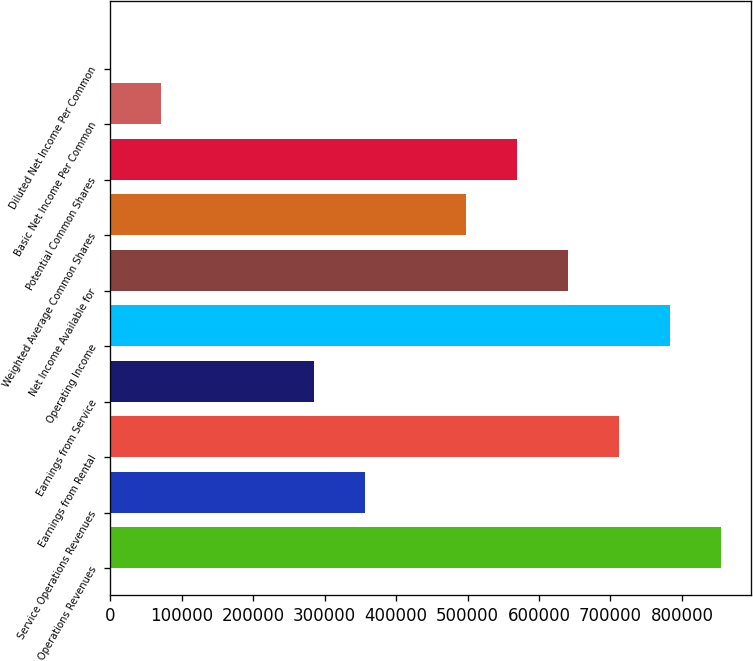Convert chart to OTSL. <chart><loc_0><loc_0><loc_500><loc_500><bar_chart><fcel>Rental Operations Revenues<fcel>Service Operations Revenues<fcel>Earnings from Rental<fcel>Earnings from Service<fcel>Operating Income<fcel>Net Income Available for<fcel>Weighted Average Common Shares<fcel>Potential Common Shares<fcel>Basic Net Income Per Common<fcel>Diluted Net Income Per Common<nl><fcel>854191<fcel>355914<fcel>711826<fcel>284731<fcel>783008<fcel>640644<fcel>498279<fcel>569461<fcel>71184.1<fcel>1.66<nl></chart> 